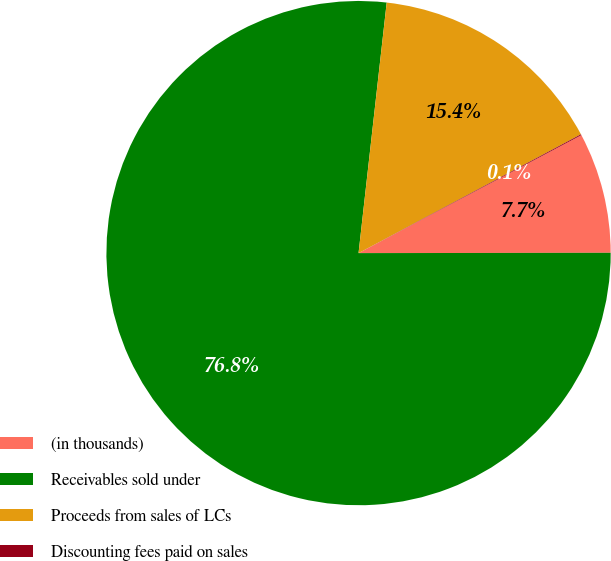Convert chart to OTSL. <chart><loc_0><loc_0><loc_500><loc_500><pie_chart><fcel>(in thousands)<fcel>Receivables sold under<fcel>Proceeds from sales of LCs<fcel>Discounting fees paid on sales<nl><fcel>7.73%<fcel>76.8%<fcel>15.41%<fcel>0.06%<nl></chart> 